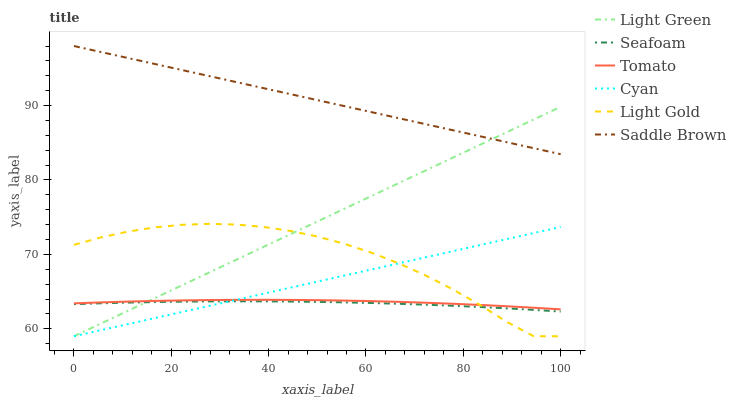Does Seafoam have the minimum area under the curve?
Answer yes or no. Yes. Does Saddle Brown have the maximum area under the curve?
Answer yes or no. Yes. Does Light Green have the minimum area under the curve?
Answer yes or no. No. Does Light Green have the maximum area under the curve?
Answer yes or no. No. Is Light Green the smoothest?
Answer yes or no. Yes. Is Light Gold the roughest?
Answer yes or no. Yes. Is Seafoam the smoothest?
Answer yes or no. No. Is Seafoam the roughest?
Answer yes or no. No. Does Light Green have the lowest value?
Answer yes or no. Yes. Does Seafoam have the lowest value?
Answer yes or no. No. Does Saddle Brown have the highest value?
Answer yes or no. Yes. Does Light Green have the highest value?
Answer yes or no. No. Is Seafoam less than Tomato?
Answer yes or no. Yes. Is Saddle Brown greater than Tomato?
Answer yes or no. Yes. Does Light Gold intersect Seafoam?
Answer yes or no. Yes. Is Light Gold less than Seafoam?
Answer yes or no. No. Is Light Gold greater than Seafoam?
Answer yes or no. No. Does Seafoam intersect Tomato?
Answer yes or no. No. 